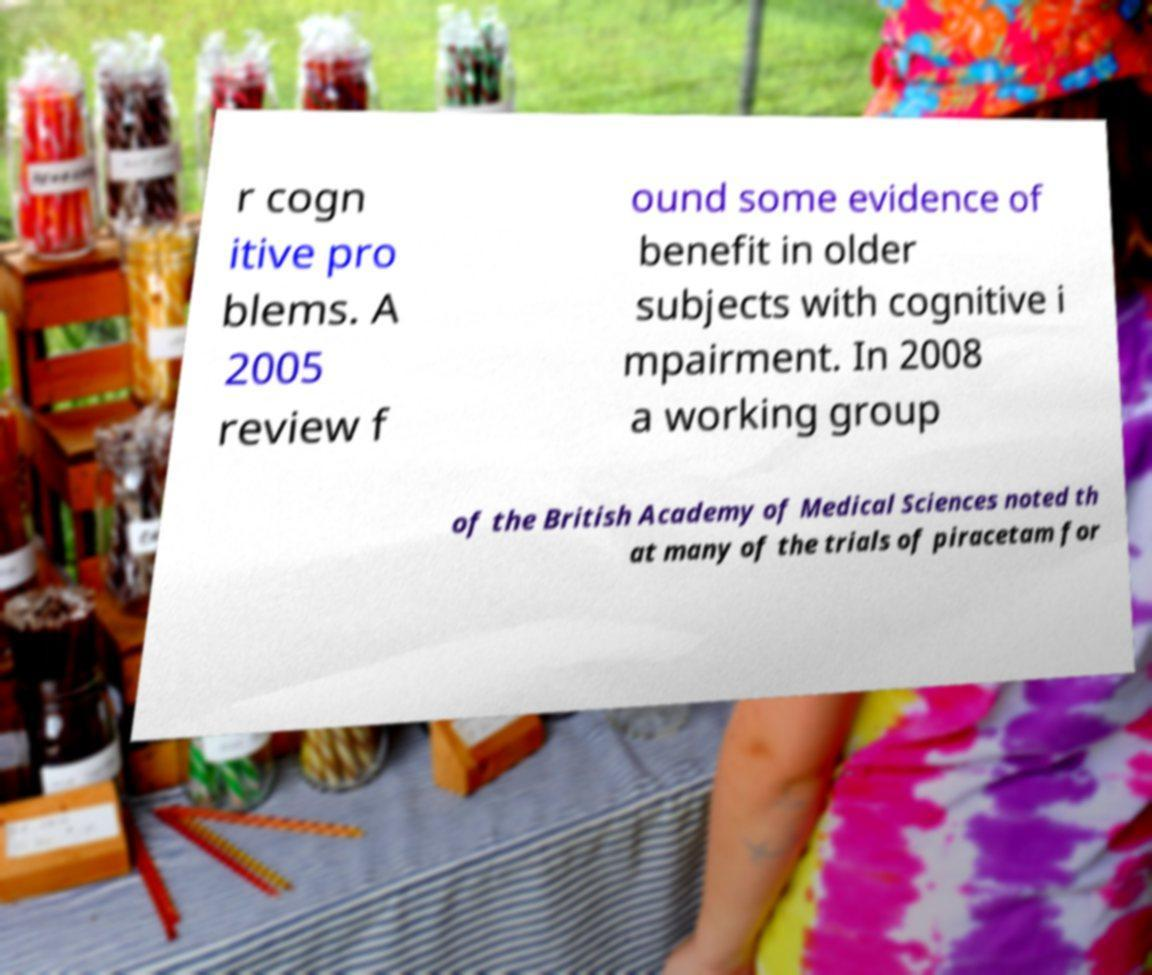Can you read and provide the text displayed in the image?This photo seems to have some interesting text. Can you extract and type it out for me? r cogn itive pro blems. A 2005 review f ound some evidence of benefit in older subjects with cognitive i mpairment. In 2008 a working group of the British Academy of Medical Sciences noted th at many of the trials of piracetam for 